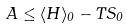<formula> <loc_0><loc_0><loc_500><loc_500>A \leq \langle H \rangle _ { 0 } - T S _ { 0 }</formula> 